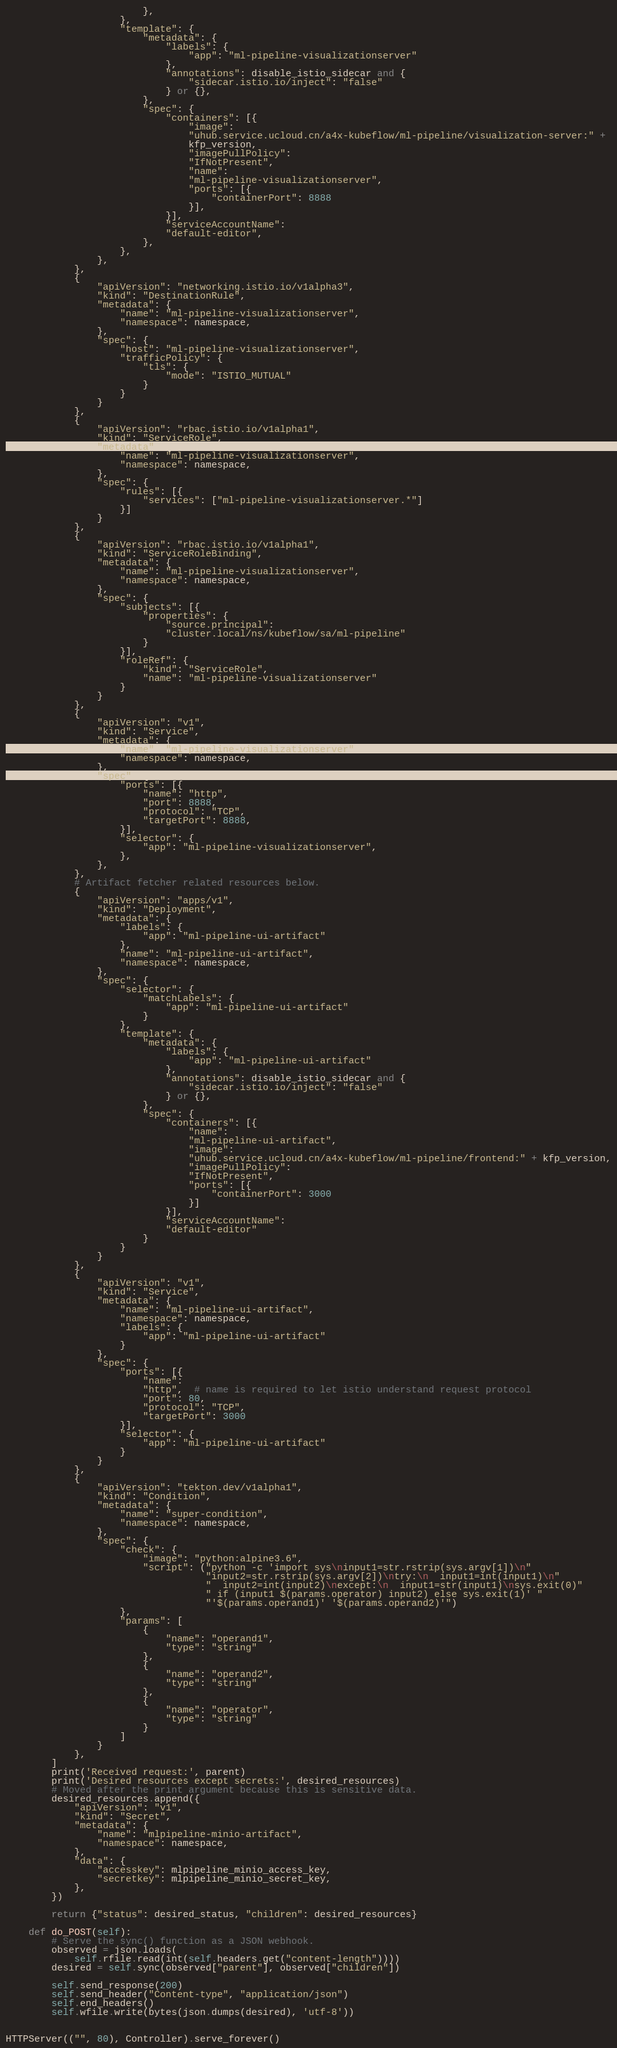Convert code to text. <code><loc_0><loc_0><loc_500><loc_500><_Python_>                        },
                    },
                    "template": {
                        "metadata": {
                            "labels": {
                                "app": "ml-pipeline-visualizationserver"
                            },
                            "annotations": disable_istio_sidecar and {
                                "sidecar.istio.io/inject": "false"
                            } or {},
                        },
                        "spec": {
                            "containers": [{
                                "image":
                                "uhub.service.ucloud.cn/a4x-kubeflow/ml-pipeline/visualization-server:" +
                                kfp_version,
                                "imagePullPolicy":
                                "IfNotPresent",
                                "name":
                                "ml-pipeline-visualizationserver",
                                "ports": [{
                                    "containerPort": 8888
                                }],
                            }],
                            "serviceAccountName":
                            "default-editor",
                        },
                    },
                },
            },
            {
                "apiVersion": "networking.istio.io/v1alpha3",
                "kind": "DestinationRule",
                "metadata": {
                    "name": "ml-pipeline-visualizationserver",
                    "namespace": namespace,
                },
                "spec": {
                    "host": "ml-pipeline-visualizationserver",
                    "trafficPolicy": {
                        "tls": {
                            "mode": "ISTIO_MUTUAL"
                        }
                    }
                }
            },
            {
                "apiVersion": "rbac.istio.io/v1alpha1",
                "kind": "ServiceRole",
                "metadata": {
                    "name": "ml-pipeline-visualizationserver",
                    "namespace": namespace,
                },
                "spec": {
                    "rules": [{
                        "services": ["ml-pipeline-visualizationserver.*"]
                    }]
                }
            },
            {
                "apiVersion": "rbac.istio.io/v1alpha1",
                "kind": "ServiceRoleBinding",
                "metadata": {
                    "name": "ml-pipeline-visualizationserver",
                    "namespace": namespace,
                },
                "spec": {
                    "subjects": [{
                        "properties": {
                            "source.principal":
                            "cluster.local/ns/kubeflow/sa/ml-pipeline"
                        }
                    }],
                    "roleRef": {
                        "kind": "ServiceRole",
                        "name": "ml-pipeline-visualizationserver"
                    }
                }
            },
            {
                "apiVersion": "v1",
                "kind": "Service",
                "metadata": {
                    "name": "ml-pipeline-visualizationserver",
                    "namespace": namespace,
                },
                "spec": {
                    "ports": [{
                        "name": "http",
                        "port": 8888,
                        "protocol": "TCP",
                        "targetPort": 8888,
                    }],
                    "selector": {
                        "app": "ml-pipeline-visualizationserver",
                    },
                },
            },
            # Artifact fetcher related resources below.
            {
                "apiVersion": "apps/v1",
                "kind": "Deployment",
                "metadata": {
                    "labels": {
                        "app": "ml-pipeline-ui-artifact"
                    },
                    "name": "ml-pipeline-ui-artifact",
                    "namespace": namespace,
                },
                "spec": {
                    "selector": {
                        "matchLabels": {
                            "app": "ml-pipeline-ui-artifact"
                        }
                    },
                    "template": {
                        "metadata": {
                            "labels": {
                                "app": "ml-pipeline-ui-artifact"
                            },
                            "annotations": disable_istio_sidecar and {
                                "sidecar.istio.io/inject": "false"
                            } or {},
                        },
                        "spec": {
                            "containers": [{
                                "name":
                                "ml-pipeline-ui-artifact",
                                "image":
                                "uhub.service.ucloud.cn/a4x-kubeflow/ml-pipeline/frontend:" + kfp_version,
                                "imagePullPolicy":
                                "IfNotPresent",
                                "ports": [{
                                    "containerPort": 3000
                                }]
                            }],
                            "serviceAccountName":
                            "default-editor"
                        }
                    }
                }
            },
            {
                "apiVersion": "v1",
                "kind": "Service",
                "metadata": {
                    "name": "ml-pipeline-ui-artifact",
                    "namespace": namespace,
                    "labels": {
                        "app": "ml-pipeline-ui-artifact"
                    }
                },
                "spec": {
                    "ports": [{
                        "name":
                        "http",  # name is required to let istio understand request protocol
                        "port": 80,
                        "protocol": "TCP",
                        "targetPort": 3000
                    }],
                    "selector": {
                        "app": "ml-pipeline-ui-artifact"
                    }
                }
            },
            {
                "apiVersion": "tekton.dev/v1alpha1",
                "kind": "Condition",
                "metadata": {
                    "name": "super-condition",
                    "namespace": namespace,
                },
                "spec": {
                    "check": {
                        "image": "python:alpine3.6",
                        "script": ("python -c 'import sys\ninput1=str.rstrip(sys.argv[1])\n"
                                   "input2=str.rstrip(sys.argv[2])\ntry:\n  input1=int(input1)\n"
                                   "  input2=int(input2)\nexcept:\n  input1=str(input1)\nsys.exit(0)"
                                   " if (input1 $(params.operator) input2) else sys.exit(1)' "
                                   "'$(params.operand1)' '$(params.operand2)'")
                    },
                    "params": [
                        {
                            "name": "operand1",
                            "type": "string"
                        },
                        {
                            "name": "operand2",
                            "type": "string"
                        },
                        {
                            "name": "operator",
                            "type": "string"
                        }
                    ]
                }
            },
        ]
        print('Received request:', parent)
        print('Desired resources except secrets:', desired_resources)
        # Moved after the print argument because this is sensitive data.
        desired_resources.append({
            "apiVersion": "v1",
            "kind": "Secret",
            "metadata": {
                "name": "mlpipeline-minio-artifact",
                "namespace": namespace,
            },
            "data": {
                "accesskey": mlpipeline_minio_access_key,
                "secretkey": mlpipeline_minio_secret_key,
            },
        })

        return {"status": desired_status, "children": desired_resources}

    def do_POST(self):
        # Serve the sync() function as a JSON webhook.
        observed = json.loads(
            self.rfile.read(int(self.headers.get("content-length"))))
        desired = self.sync(observed["parent"], observed["children"])

        self.send_response(200)
        self.send_header("Content-type", "application/json")
        self.end_headers()
        self.wfile.write(bytes(json.dumps(desired), 'utf-8'))


HTTPServer(("", 80), Controller).serve_forever()
</code> 